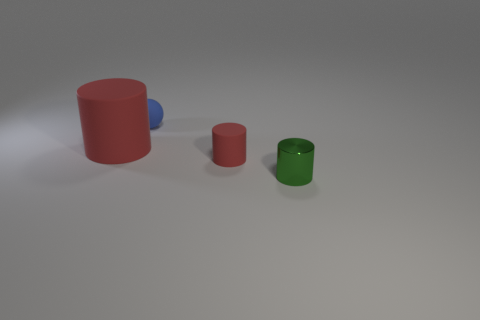Subtract all small metallic cylinders. How many cylinders are left? 2 Add 2 blue things. How many objects exist? 6 Subtract all green cylinders. How many cylinders are left? 2 Subtract all small matte cylinders. Subtract all small cylinders. How many objects are left? 1 Add 1 blue matte balls. How many blue matte balls are left? 2 Add 1 large matte objects. How many large matte objects exist? 2 Subtract 0 yellow blocks. How many objects are left? 4 Subtract all balls. How many objects are left? 3 Subtract 1 cylinders. How many cylinders are left? 2 Subtract all gray cylinders. Subtract all yellow blocks. How many cylinders are left? 3 